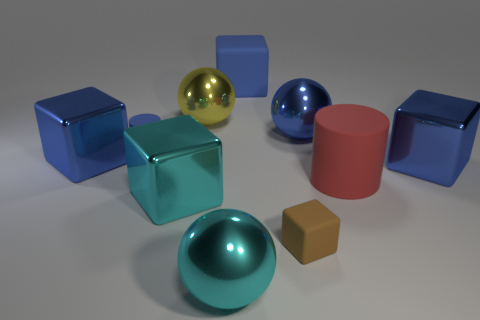Subtract all brown cylinders. How many blue blocks are left? 3 Subtract all cyan cubes. How many cubes are left? 4 Subtract all small brown rubber cubes. How many cubes are left? 4 Subtract 3 cubes. How many cubes are left? 2 Subtract all gray blocks. Subtract all cyan cylinders. How many blocks are left? 5 Subtract all cylinders. How many objects are left? 8 Add 2 shiny spheres. How many shiny spheres exist? 5 Subtract 0 green balls. How many objects are left? 10 Subtract all cyan metallic balls. Subtract all blue shiny spheres. How many objects are left? 8 Add 2 rubber cylinders. How many rubber cylinders are left? 4 